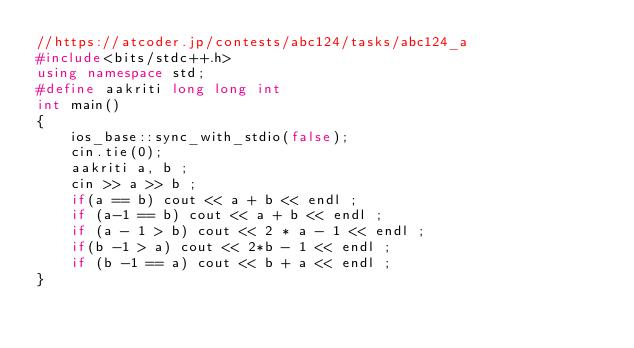Convert code to text. <code><loc_0><loc_0><loc_500><loc_500><_C++_>//https://atcoder.jp/contests/abc124/tasks/abc124_a
#include<bits/stdc++.h>
using namespace std;
#define aakriti long long int
int main()
{
    ios_base::sync_with_stdio(false);
    cin.tie(0);    
    aakriti a, b ;
    cin >> a >> b ;
    if(a == b) cout << a + b << endl ;
    if (a-1 == b) cout << a + b << endl ;
    if (a - 1 > b) cout << 2 * a - 1 << endl ;
    if(b -1 > a) cout << 2*b - 1 << endl ;
    if (b -1 == a) cout << b + a << endl ;
}</code> 